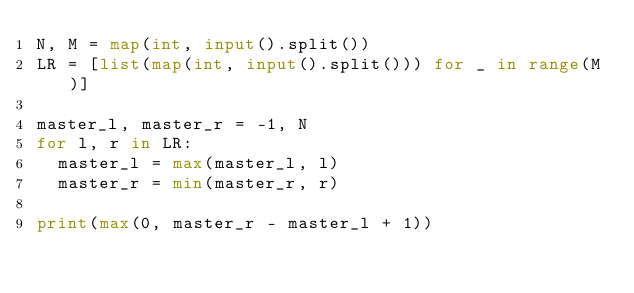Convert code to text. <code><loc_0><loc_0><loc_500><loc_500><_Python_>N, M = map(int, input().split())
LR = [list(map(int, input().split())) for _ in range(M)]

master_l, master_r = -1, N
for l, r in LR:
	master_l = max(master_l, l)
	master_r = min(master_r, r)

print(max(0, master_r - master_l + 1))
</code> 